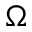Convert formula to latex. <formula><loc_0><loc_0><loc_500><loc_500>\Omega</formula> 